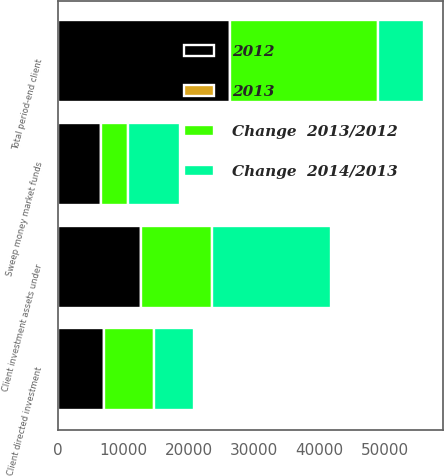Convert chart. <chart><loc_0><loc_0><loc_500><loc_500><stacked_bar_chart><ecel><fcel>Client directed investment<fcel>Client investment assets under<fcel>Sweep money market funds<fcel>Total period-end client<nl><fcel>Change  2014/2013<fcel>6158<fcel>18253<fcel>7957<fcel>7073<nl><fcel>2012<fcel>7073<fcel>12689<fcel>6601<fcel>26363<nl><fcel>2013<fcel>12.9<fcel>43.8<fcel>20.5<fcel>22.8<nl><fcel>Change  2013/2012<fcel>7604<fcel>10824<fcel>4085<fcel>22513<nl></chart> 